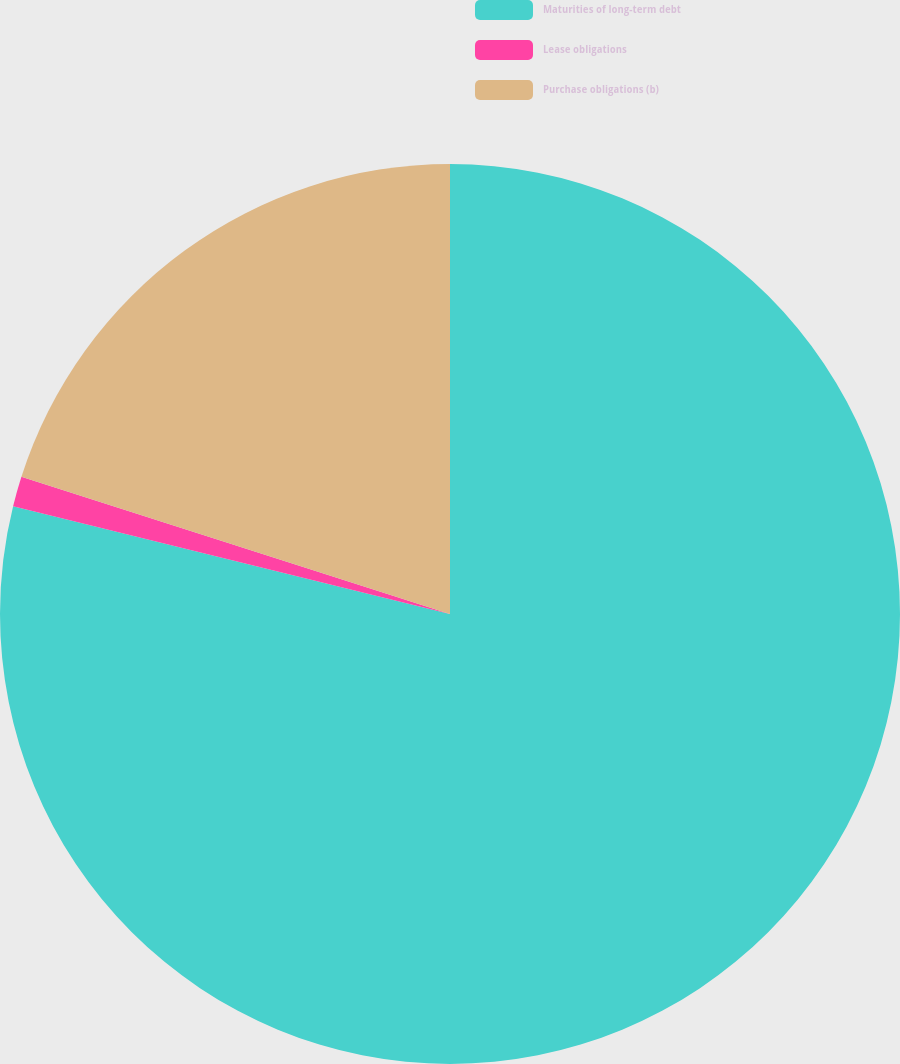Convert chart to OTSL. <chart><loc_0><loc_0><loc_500><loc_500><pie_chart><fcel>Maturities of long-term debt<fcel>Lease obligations<fcel>Purchase obligations (b)<nl><fcel>78.85%<fcel>1.08%<fcel>20.07%<nl></chart> 